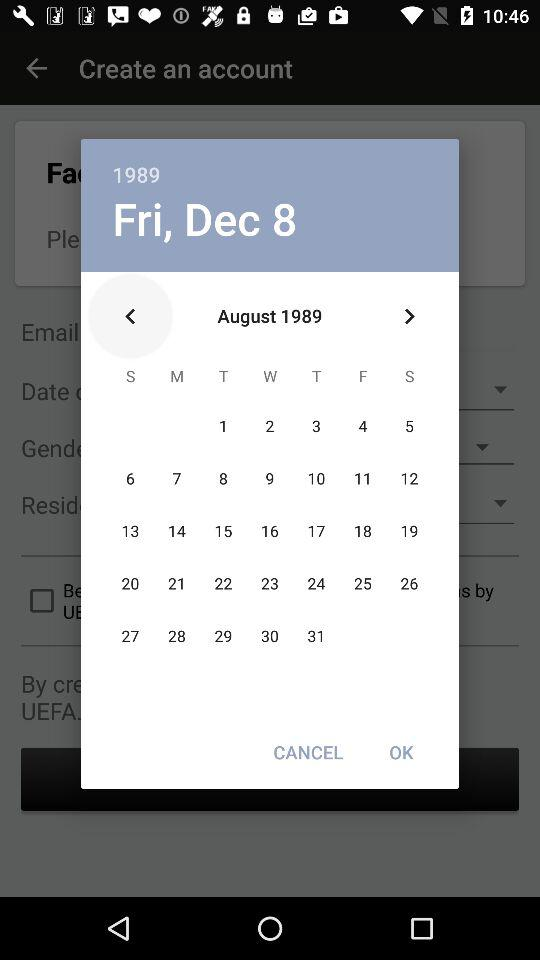What is the year? The year is 1989. 